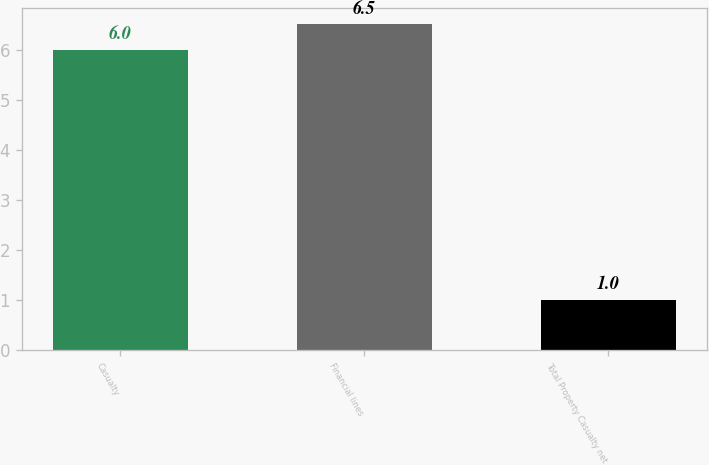<chart> <loc_0><loc_0><loc_500><loc_500><bar_chart><fcel>Casualty<fcel>Financial lines<fcel>Total Property Casualty net<nl><fcel>6<fcel>6.5<fcel>1<nl></chart> 